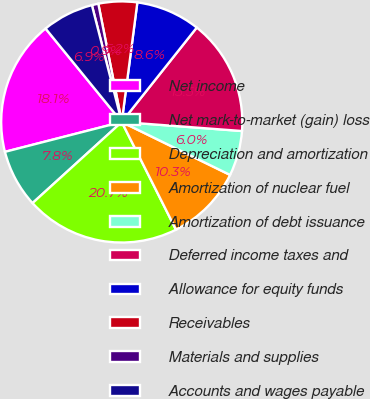Convert chart to OTSL. <chart><loc_0><loc_0><loc_500><loc_500><pie_chart><fcel>Net income<fcel>Net mark-to-market (gain) loss<fcel>Depreciation and amortization<fcel>Amortization of nuclear fuel<fcel>Amortization of debt issuance<fcel>Deferred income taxes and<fcel>Allowance for equity funds<fcel>Receivables<fcel>Materials and supplies<fcel>Accounts and wages payable<nl><fcel>18.1%<fcel>7.76%<fcel>20.68%<fcel>10.34%<fcel>6.04%<fcel>15.51%<fcel>8.62%<fcel>5.18%<fcel>0.87%<fcel>6.9%<nl></chart> 